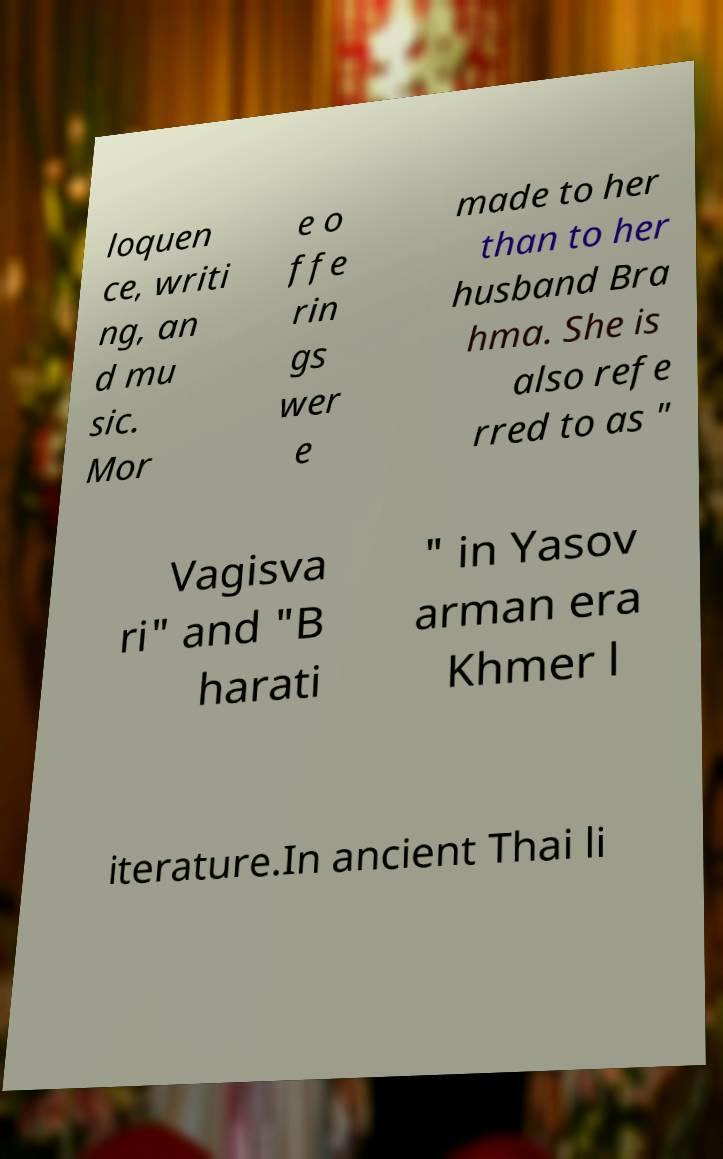Please identify and transcribe the text found in this image. loquen ce, writi ng, an d mu sic. Mor e o ffe rin gs wer e made to her than to her husband Bra hma. She is also refe rred to as " Vagisva ri" and "B harati " in Yasov arman era Khmer l iterature.In ancient Thai li 